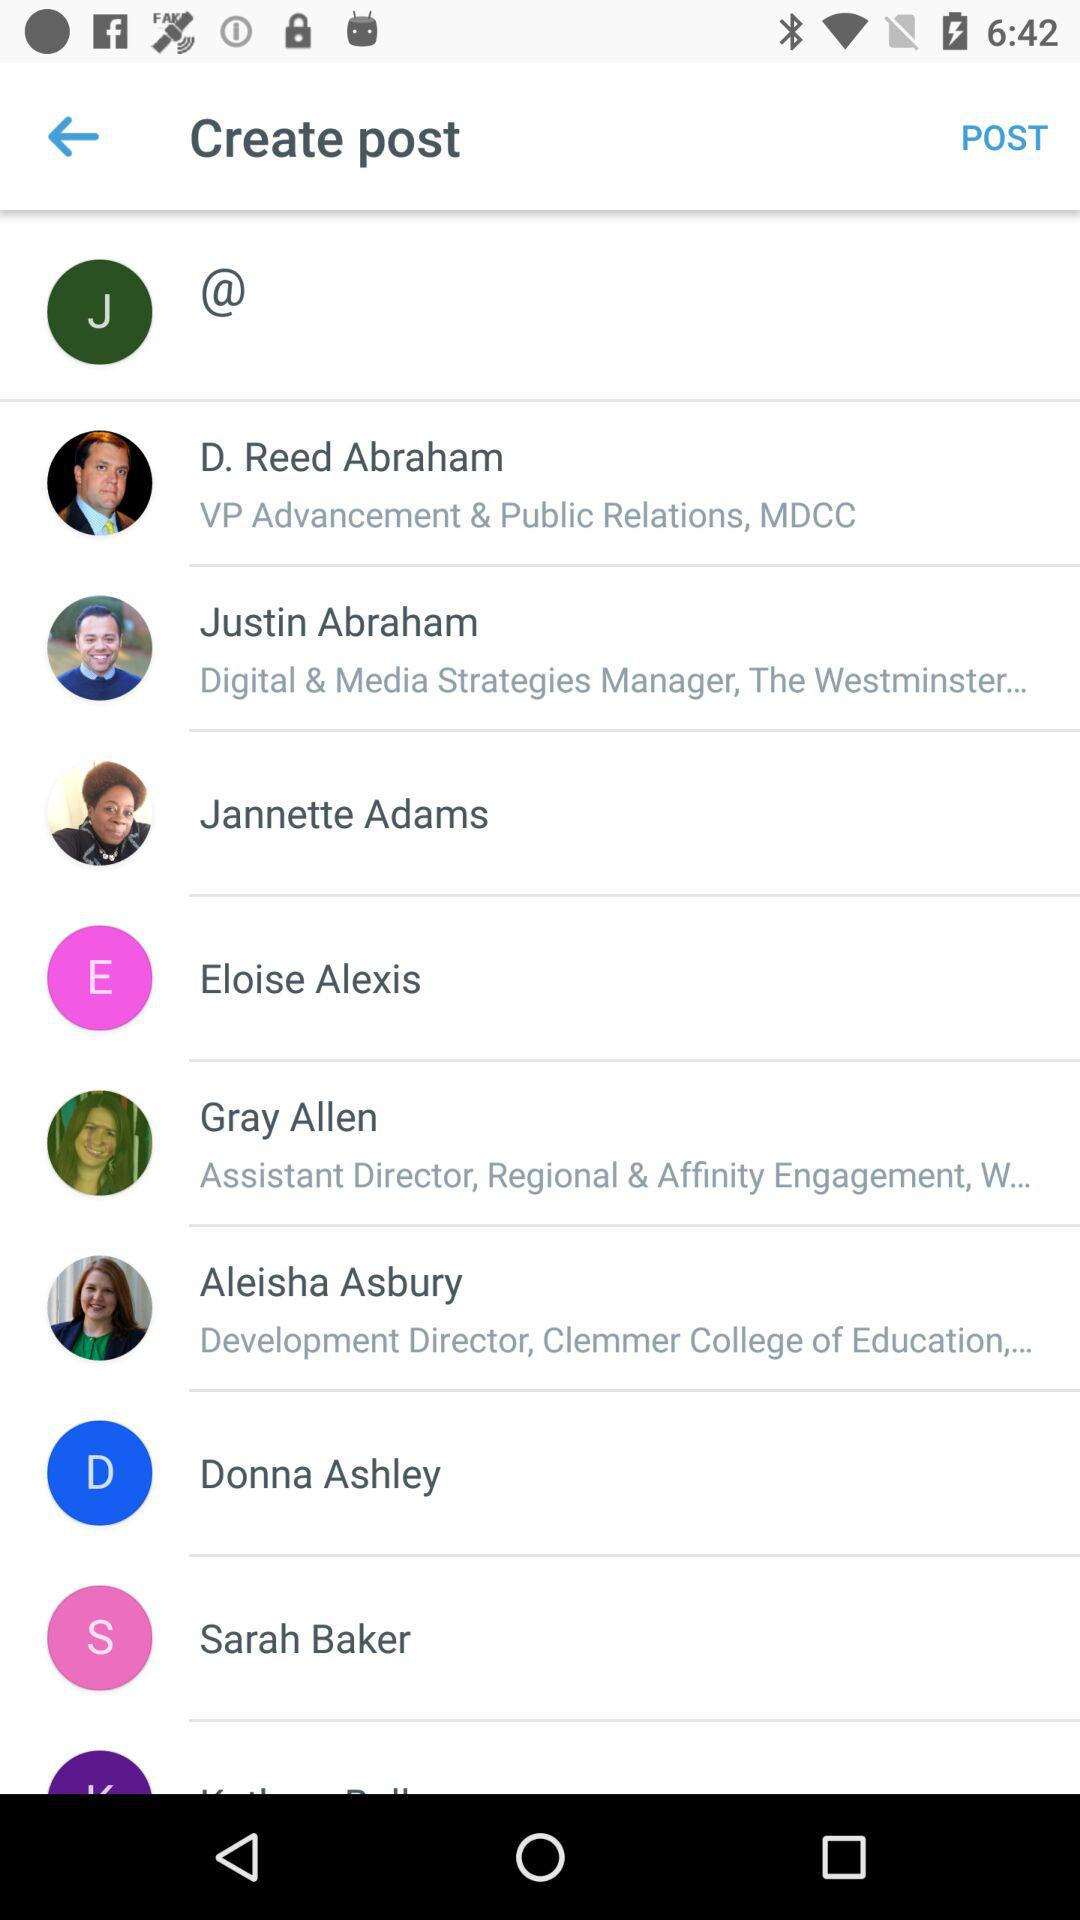Who is the Development Director? The name of the Development Director is Aleisha Asbury. 